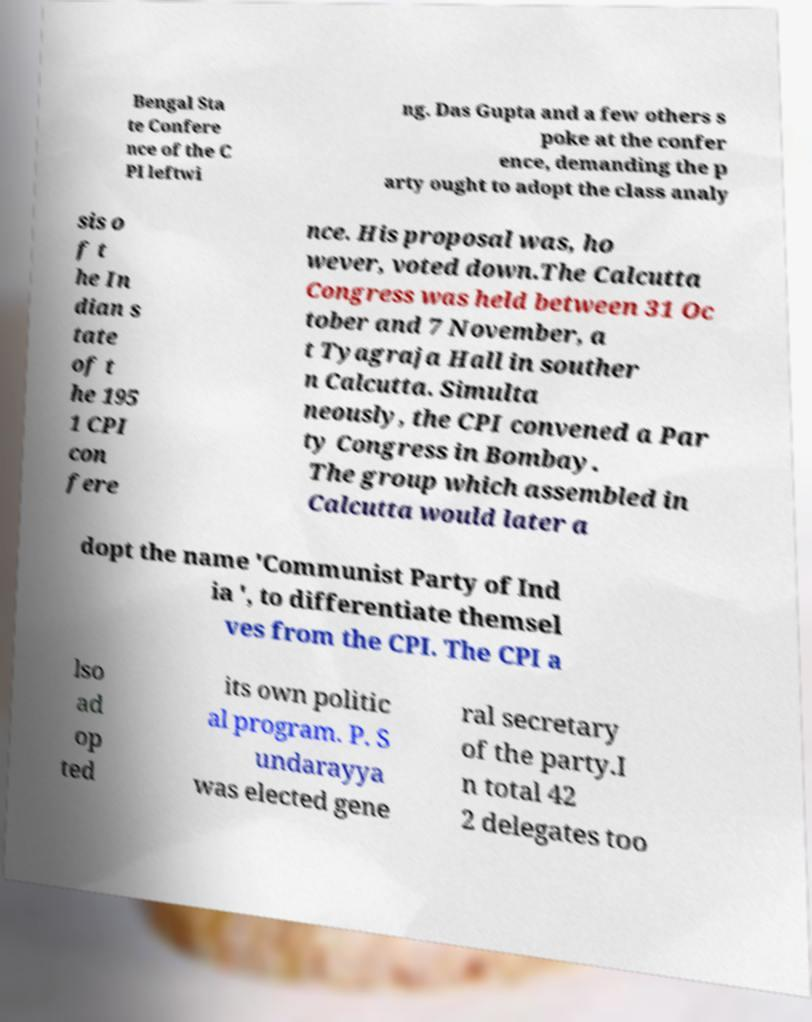Can you accurately transcribe the text from the provided image for me? Bengal Sta te Confere nce of the C PI leftwi ng. Das Gupta and a few others s poke at the confer ence, demanding the p arty ought to adopt the class analy sis o f t he In dian s tate of t he 195 1 CPI con fere nce. His proposal was, ho wever, voted down.The Calcutta Congress was held between 31 Oc tober and 7 November, a t Tyagraja Hall in souther n Calcutta. Simulta neously, the CPI convened a Par ty Congress in Bombay. The group which assembled in Calcutta would later a dopt the name 'Communist Party of Ind ia ', to differentiate themsel ves from the CPI. The CPI a lso ad op ted its own politic al program. P. S undarayya was elected gene ral secretary of the party.I n total 42 2 delegates too 